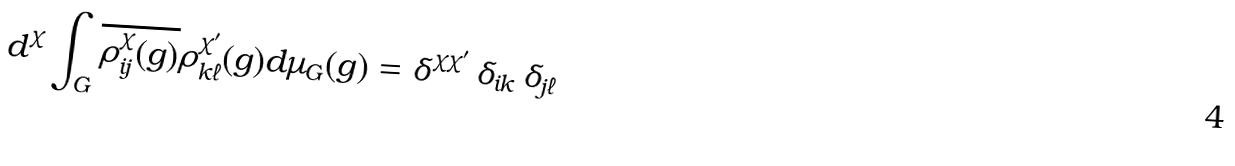Convert formula to latex. <formula><loc_0><loc_0><loc_500><loc_500>d ^ { \chi } \int _ { G } \overline { \rho ^ { \chi } _ { i j } ( g ) } \rho ^ { \chi ^ { \prime } } _ { k \ell } ( g ) d \mu _ { G } ( g ) = \delta ^ { \chi \chi ^ { \prime } } \, \delta _ { i k } \, \delta _ { j \ell }</formula> 